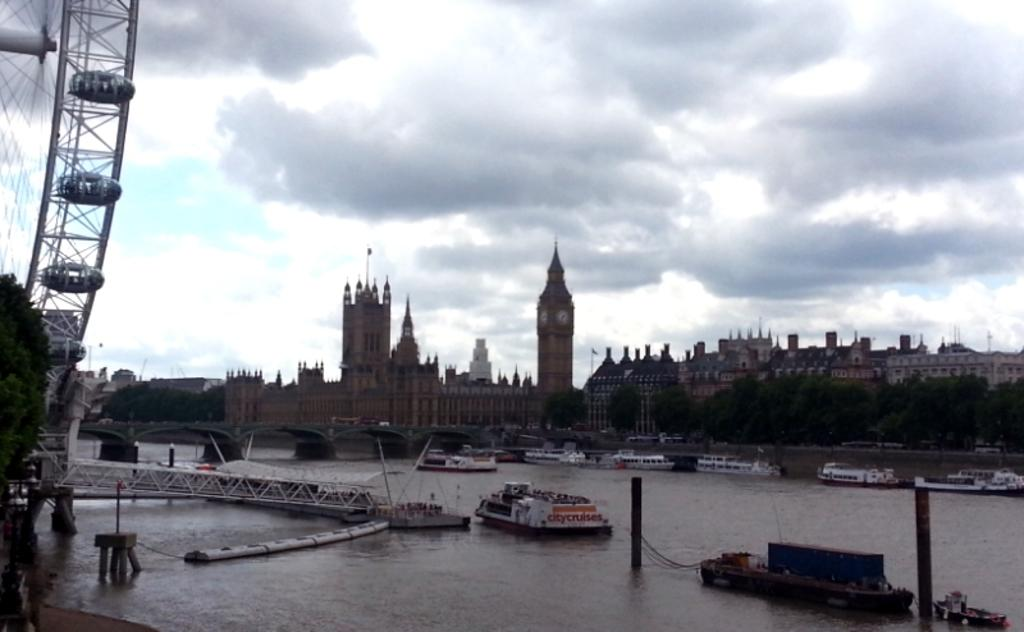What can be seen at the bottom of the image? There are boats in the water at the bottom of the image. What type of vegetation is on the right side of the image? There are trees on the right side of the image. What structures are located in the middle of the image? There are houses and buildings in the middle of the image. What is visible at the top of the image? The sky is visible at the top of the image. How would you describe the sky in the image? The sky appears to be cloudy. What type of watch can be seen on the action system in the image? There is no watch or action system present in the image. 